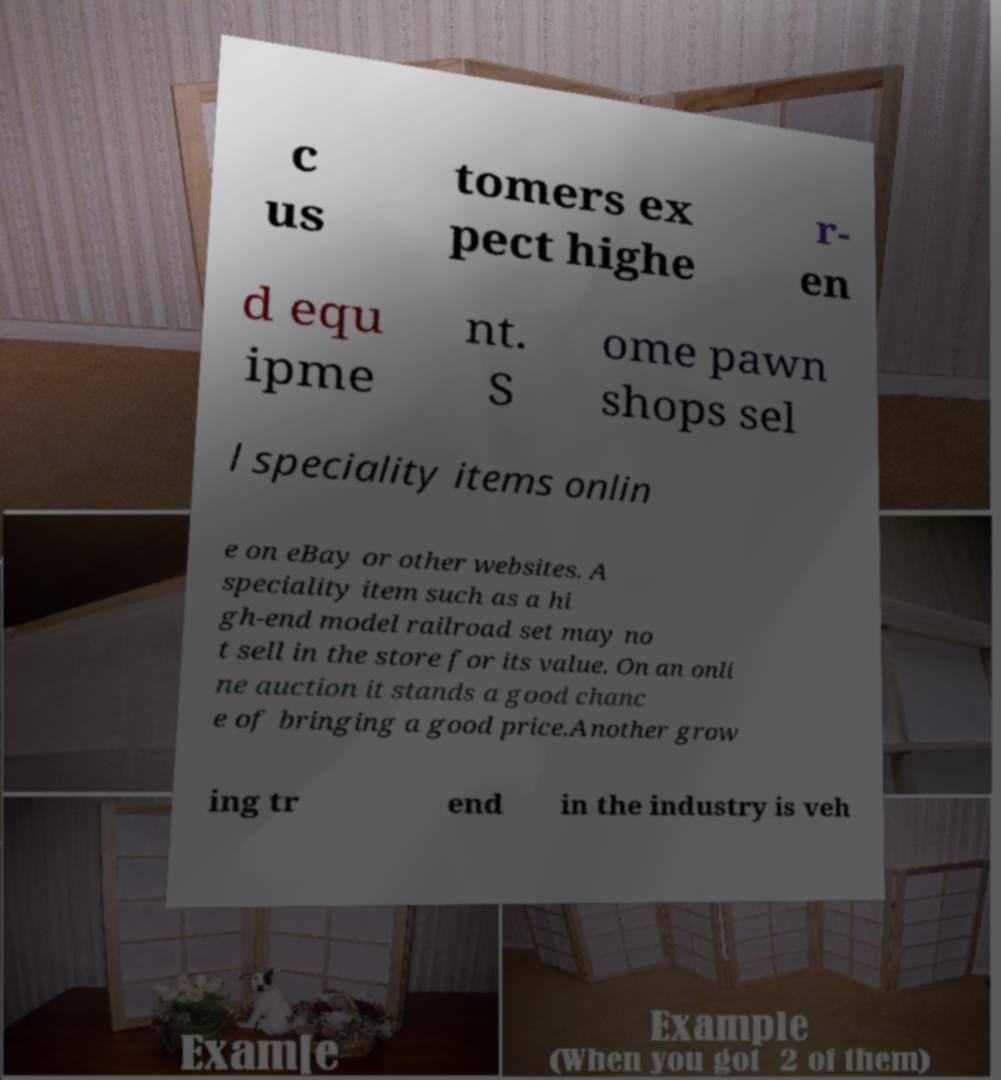There's text embedded in this image that I need extracted. Can you transcribe it verbatim? c us tomers ex pect highe r- en d equ ipme nt. S ome pawn shops sel l speciality items onlin e on eBay or other websites. A speciality item such as a hi gh-end model railroad set may no t sell in the store for its value. On an onli ne auction it stands a good chanc e of bringing a good price.Another grow ing tr end in the industry is veh 